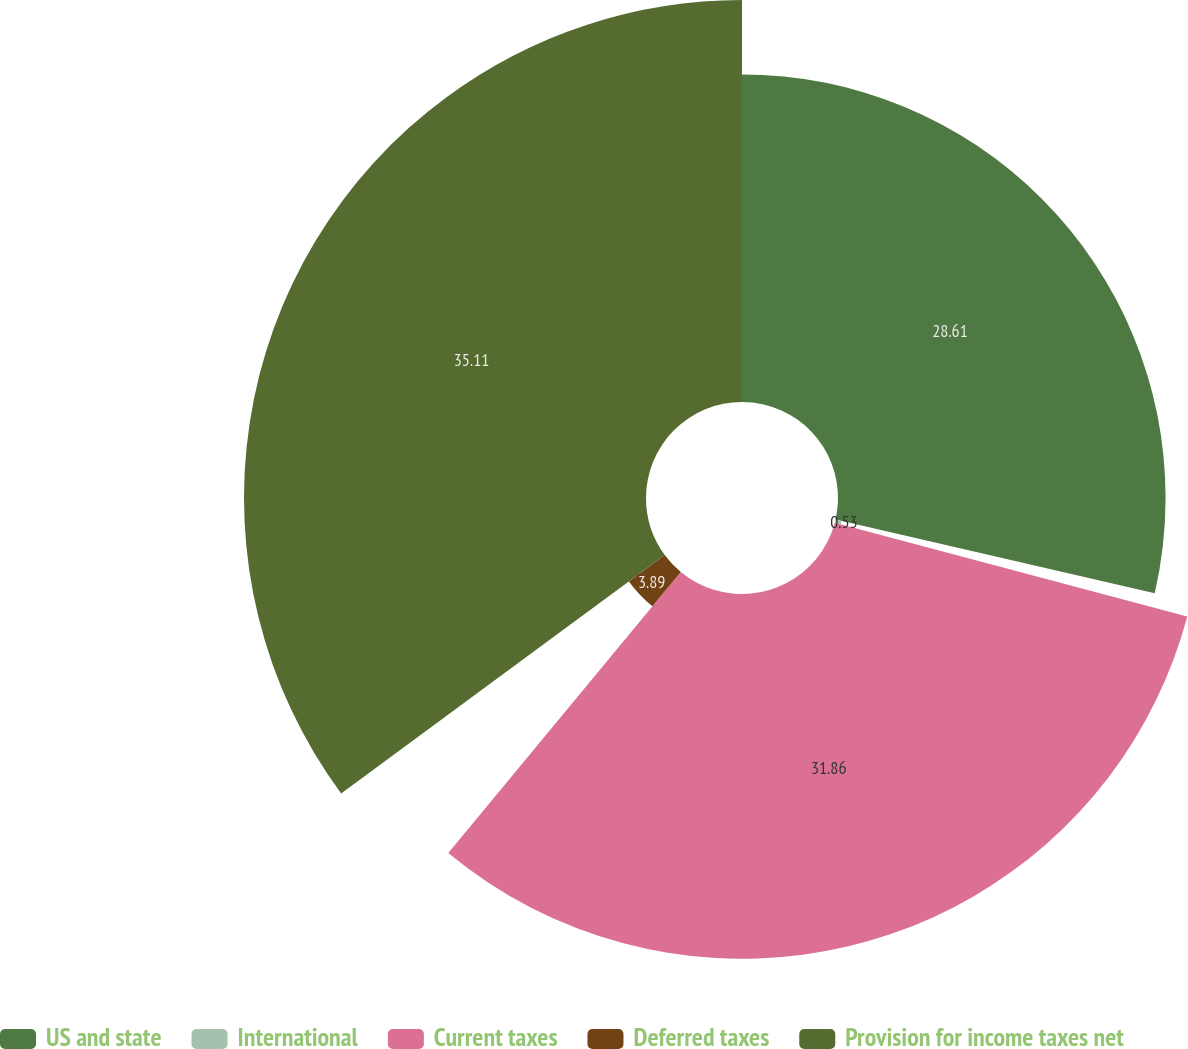<chart> <loc_0><loc_0><loc_500><loc_500><pie_chart><fcel>US and state<fcel>International<fcel>Current taxes<fcel>Deferred taxes<fcel>Provision for income taxes net<nl><fcel>28.61%<fcel>0.53%<fcel>31.86%<fcel>3.89%<fcel>35.11%<nl></chart> 